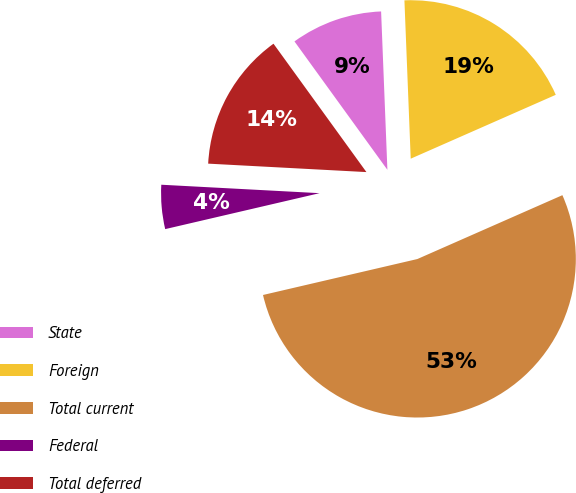Convert chart. <chart><loc_0><loc_0><loc_500><loc_500><pie_chart><fcel>State<fcel>Foreign<fcel>Total current<fcel>Federal<fcel>Total deferred<nl><fcel>9.34%<fcel>19.03%<fcel>52.96%<fcel>4.49%<fcel>14.18%<nl></chart> 